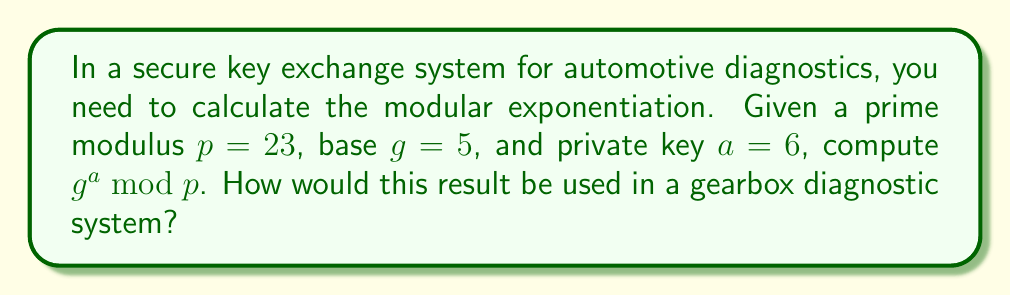Could you help me with this problem? To calculate the modular exponentiation $g^a \bmod p$, we'll use the following steps:

1) We have $g = 5$, $a = 6$, and $p = 23$.

2) We need to calculate $5^6 \bmod 23$.

3) Let's break this down step by step:
   
   $5^1 \bmod 23 = 5$
   $5^2 \bmod 23 = 25 \bmod 23 = 2$
   $5^3 \bmod 23 = 5 \cdot 2 \bmod 23 = 10$
   $5^4 \bmod 23 = 10 \cdot 5 \bmod 23 = 50 \bmod 23 = 4$
   $5^5 \bmod 23 = 4 \cdot 5 \bmod 23 = 20$
   $5^6 \bmod 23 = 20 \cdot 5 \bmod 23 = 100 \bmod 23 = 8$

4) Therefore, $g^a \bmod p = 5^6 \bmod 23 = 8$.

In a gearbox diagnostic system, this result (8) would be used as part of the public key. When transmitting sensitive data about gearbox performance or receiving software updates for the gearbox control unit, this key helps ensure that only authorized devices can decrypt the information. This prevents unauthorized access to critical gearbox parameters and protects against potential cyber attacks that could compromise gearbox functionality or vehicle safety.
Answer: $8$ 